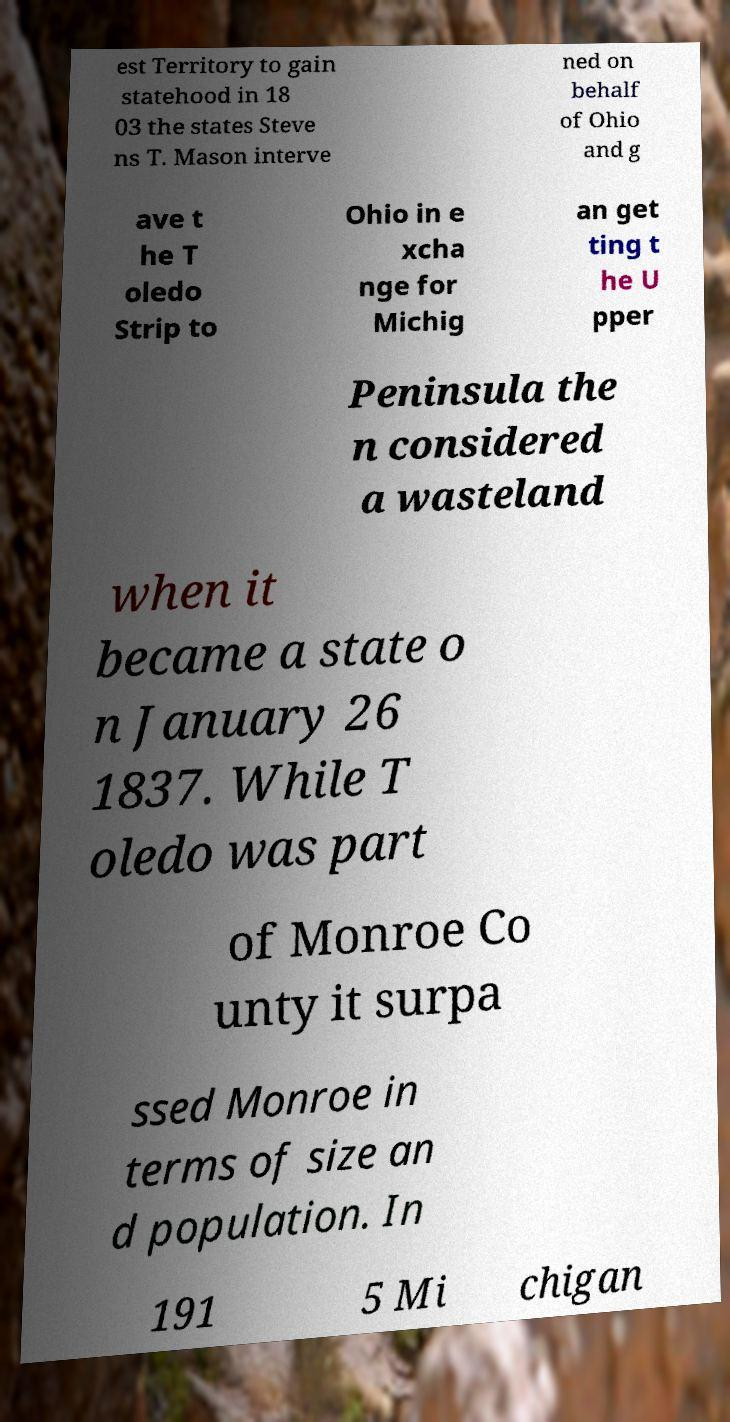I need the written content from this picture converted into text. Can you do that? est Territory to gain statehood in 18 03 the states Steve ns T. Mason interve ned on behalf of Ohio and g ave t he T oledo Strip to Ohio in e xcha nge for Michig an get ting t he U pper Peninsula the n considered a wasteland when it became a state o n January 26 1837. While T oledo was part of Monroe Co unty it surpa ssed Monroe in terms of size an d population. In 191 5 Mi chigan 